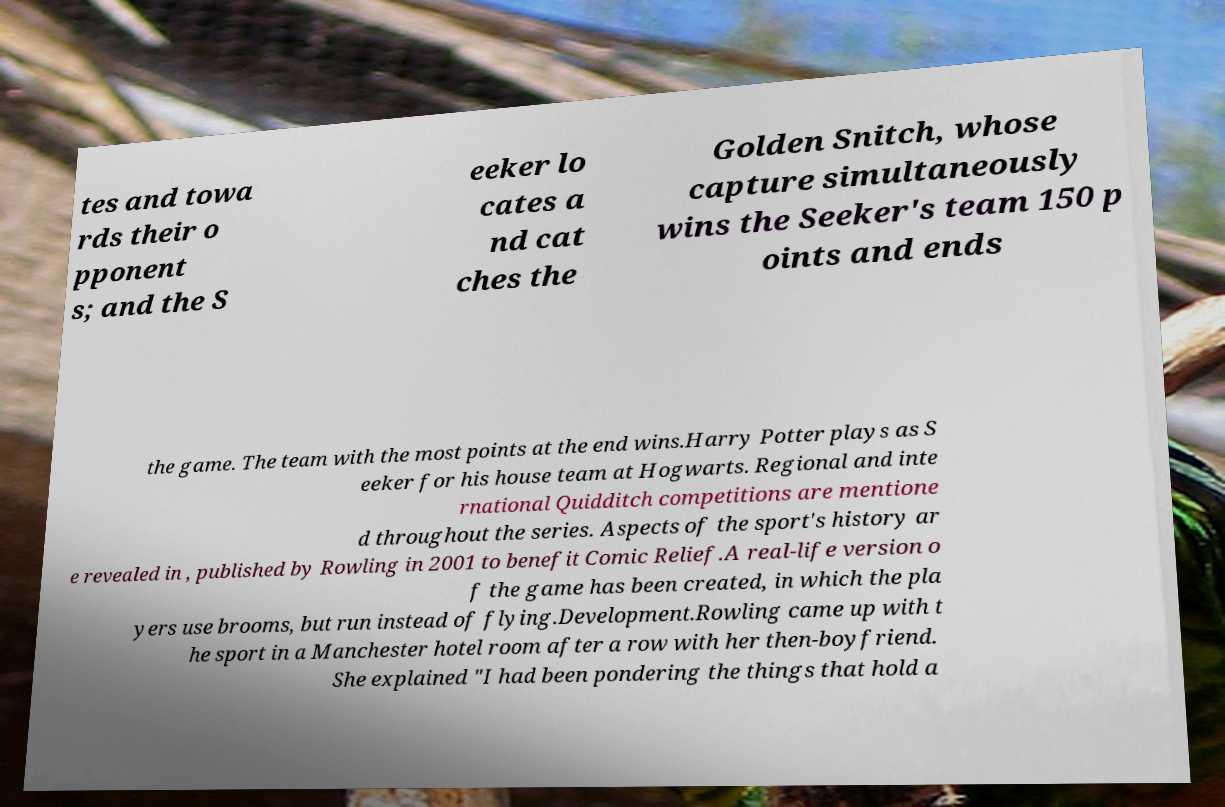I need the written content from this picture converted into text. Can you do that? tes and towa rds their o pponent s; and the S eeker lo cates a nd cat ches the Golden Snitch, whose capture simultaneously wins the Seeker's team 150 p oints and ends the game. The team with the most points at the end wins.Harry Potter plays as S eeker for his house team at Hogwarts. Regional and inte rnational Quidditch competitions are mentione d throughout the series. Aspects of the sport's history ar e revealed in , published by Rowling in 2001 to benefit Comic Relief.A real-life version o f the game has been created, in which the pla yers use brooms, but run instead of flying.Development.Rowling came up with t he sport in a Manchester hotel room after a row with her then-boyfriend. She explained "I had been pondering the things that hold a 